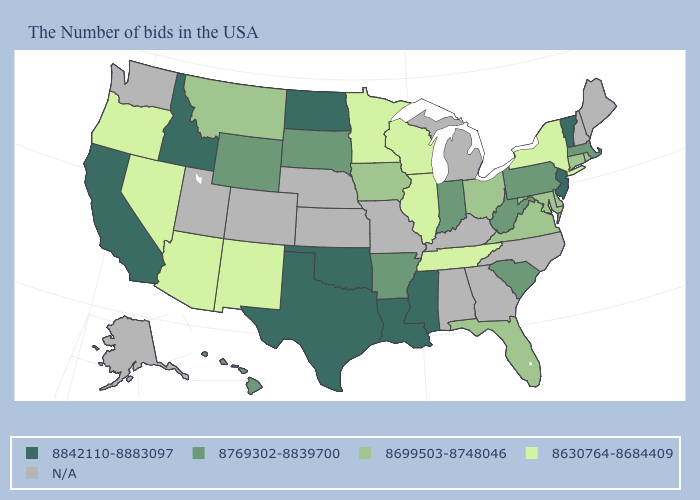Which states have the highest value in the USA?
Be succinct. Vermont, New Jersey, Mississippi, Louisiana, Oklahoma, Texas, North Dakota, Idaho, California. What is the value of Virginia?
Concise answer only. 8699503-8748046. What is the highest value in the USA?
Concise answer only. 8842110-8883097. What is the value of Iowa?
Give a very brief answer. 8699503-8748046. Does Tennessee have the lowest value in the USA?
Answer briefly. Yes. How many symbols are there in the legend?
Give a very brief answer. 5. Which states hav the highest value in the South?
Be succinct. Mississippi, Louisiana, Oklahoma, Texas. What is the value of Kansas?
Write a very short answer. N/A. What is the highest value in the USA?
Short answer required. 8842110-8883097. Name the states that have a value in the range 8630764-8684409?
Concise answer only. New York, Tennessee, Wisconsin, Illinois, Minnesota, New Mexico, Arizona, Nevada, Oregon. Name the states that have a value in the range 8842110-8883097?
Short answer required. Vermont, New Jersey, Mississippi, Louisiana, Oklahoma, Texas, North Dakota, Idaho, California. What is the value of Oklahoma?
Keep it brief. 8842110-8883097. What is the value of Connecticut?
Be succinct. 8699503-8748046. Which states have the lowest value in the South?
Be succinct. Tennessee. 